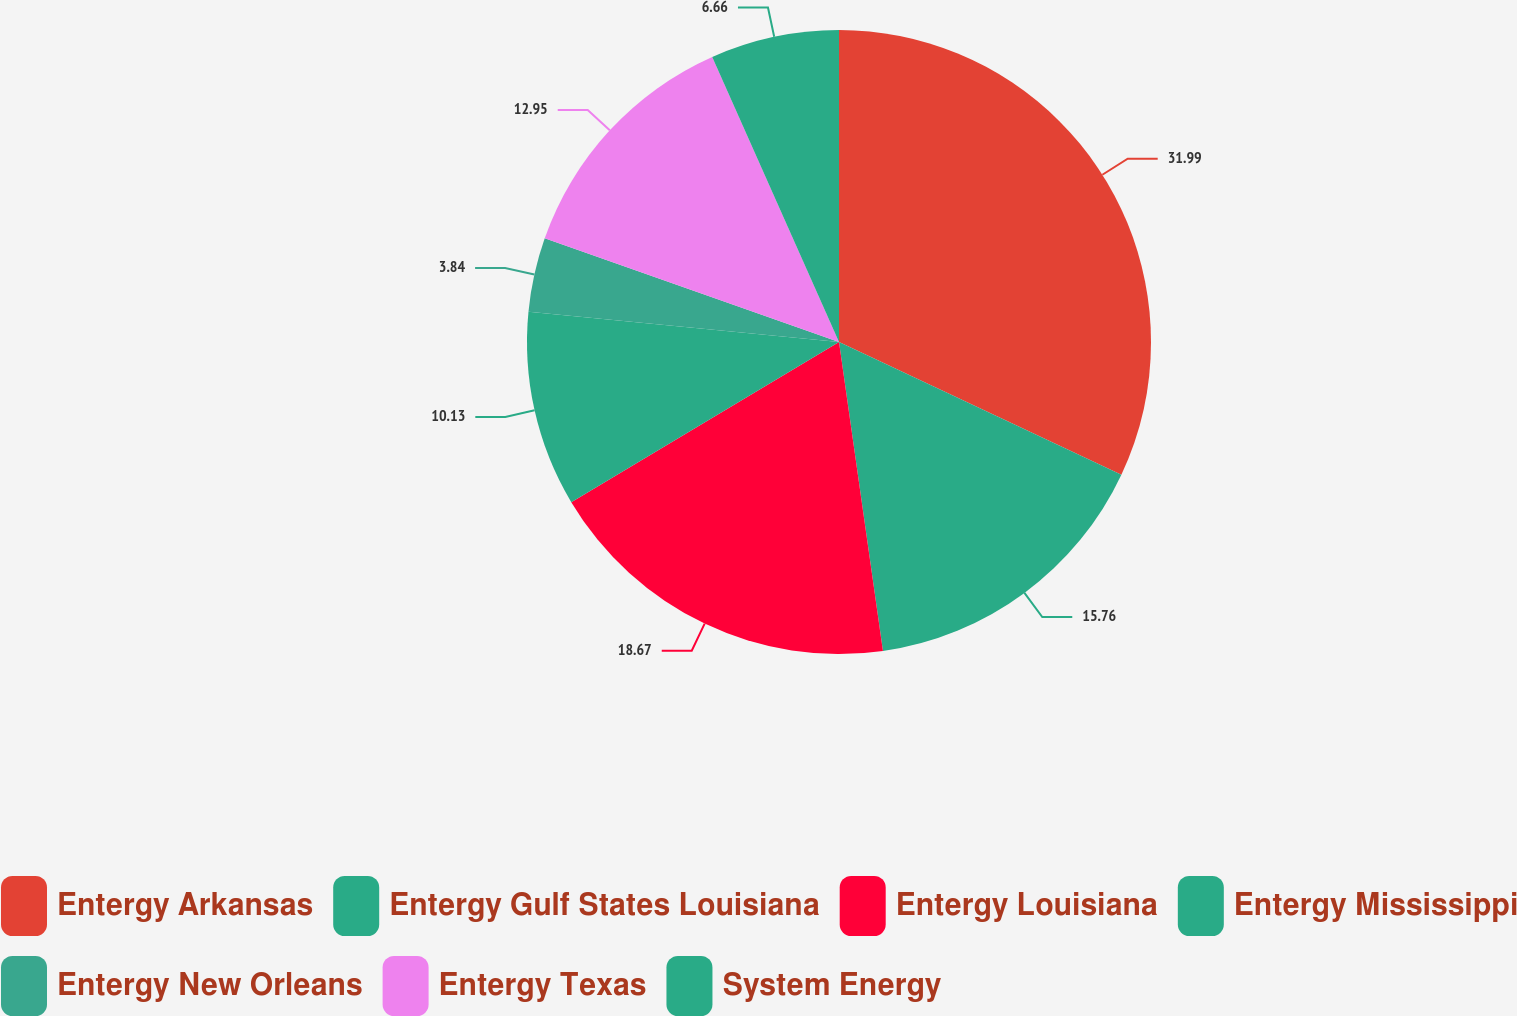Convert chart to OTSL. <chart><loc_0><loc_0><loc_500><loc_500><pie_chart><fcel>Entergy Arkansas<fcel>Entergy Gulf States Louisiana<fcel>Entergy Louisiana<fcel>Entergy Mississippi<fcel>Entergy New Orleans<fcel>Entergy Texas<fcel>System Energy<nl><fcel>31.99%<fcel>15.76%<fcel>18.67%<fcel>10.13%<fcel>3.84%<fcel>12.95%<fcel>6.66%<nl></chart> 